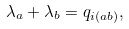<formula> <loc_0><loc_0><loc_500><loc_500>\lambda _ { a } + \lambda _ { b } = q _ { i ( a b ) } ,</formula> 